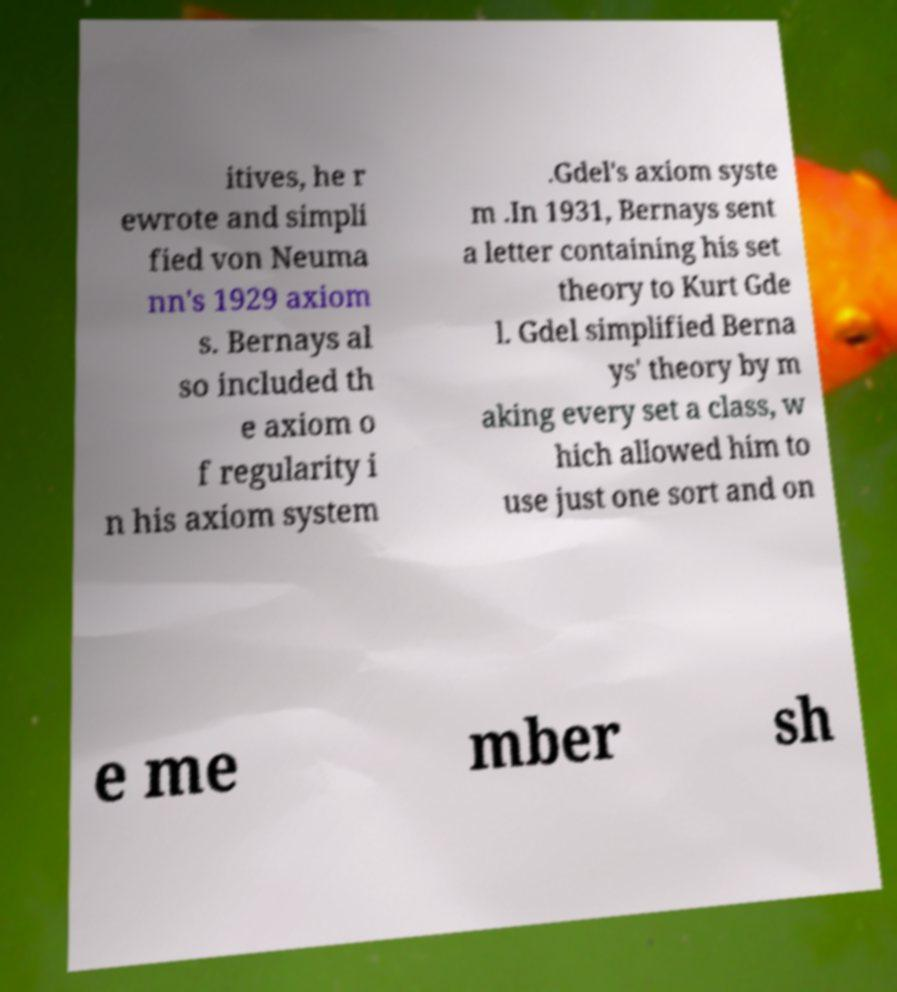Please read and relay the text visible in this image. What does it say? itives, he r ewrote and simpli fied von Neuma nn's 1929 axiom s. Bernays al so included th e axiom o f regularity i n his axiom system .Gdel's axiom syste m .In 1931, Bernays sent a letter containing his set theory to Kurt Gde l. Gdel simplified Berna ys' theory by m aking every set a class, w hich allowed him to use just one sort and on e me mber sh 